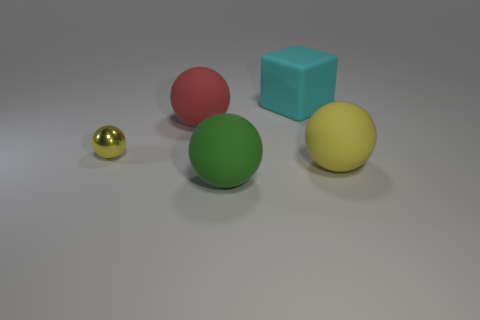How many cyan objects have the same shape as the big red thing?
Make the answer very short. 0. There is a yellow shiny sphere behind the sphere that is to the right of the rubber cube; how big is it?
Provide a short and direct response. Small. Do the large ball behind the small yellow metallic sphere and the sphere on the right side of the green rubber ball have the same color?
Offer a very short reply. No. There is a rubber sphere that is on the right side of the cyan rubber cube right of the small yellow shiny thing; what number of big things are behind it?
Your answer should be compact. 2. What number of big rubber objects are both behind the tiny yellow sphere and right of the rubber block?
Provide a succinct answer. 0. Are there more yellow matte balls behind the large cyan rubber block than tiny green metal balls?
Ensure brevity in your answer.  No. How many rubber cubes are the same size as the green matte ball?
Provide a succinct answer. 1. There is a sphere that is the same color as the tiny thing; what size is it?
Offer a terse response. Large. What number of small things are shiny things or green balls?
Ensure brevity in your answer.  1. How many big balls are there?
Provide a short and direct response. 3. 